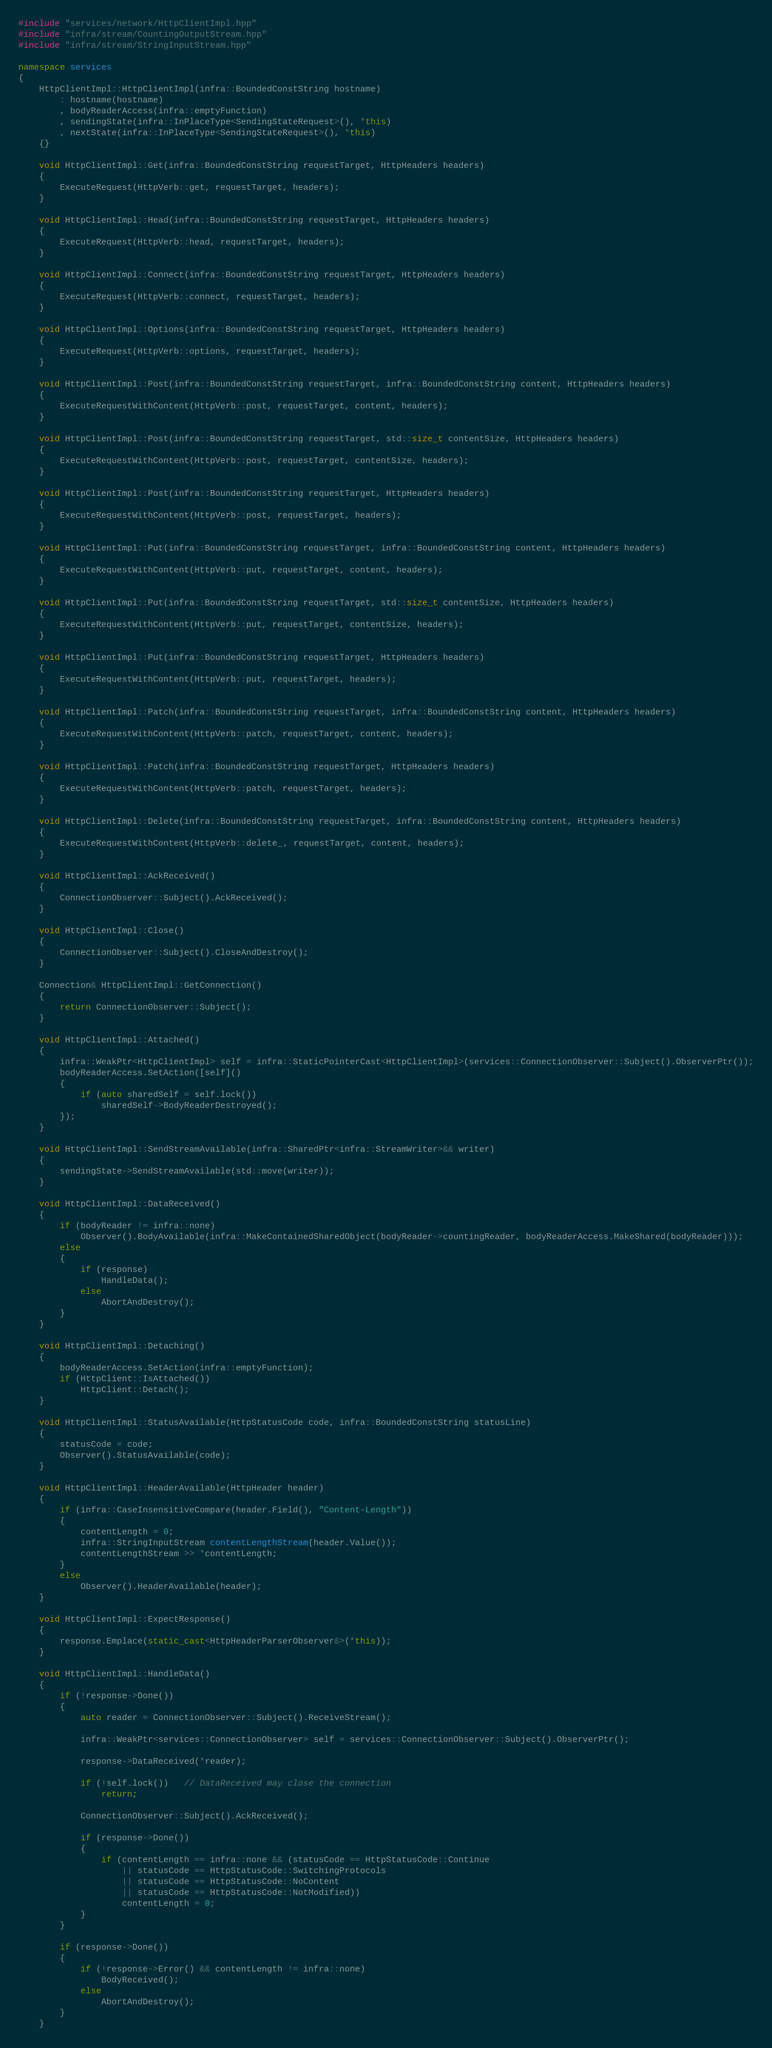<code> <loc_0><loc_0><loc_500><loc_500><_C++_>#include "services/network/HttpClientImpl.hpp"
#include "infra/stream/CountingOutputStream.hpp"
#include "infra/stream/StringInputStream.hpp"

namespace services
{
    HttpClientImpl::HttpClientImpl(infra::BoundedConstString hostname)
        : hostname(hostname)
        , bodyReaderAccess(infra::emptyFunction)
        , sendingState(infra::InPlaceType<SendingStateRequest>(), *this)
        , nextState(infra::InPlaceType<SendingStateRequest>(), *this)
    {}

    void HttpClientImpl::Get(infra::BoundedConstString requestTarget, HttpHeaders headers)
    {
        ExecuteRequest(HttpVerb::get, requestTarget, headers);
    }

    void HttpClientImpl::Head(infra::BoundedConstString requestTarget, HttpHeaders headers)
    {
        ExecuteRequest(HttpVerb::head, requestTarget, headers);
    }

    void HttpClientImpl::Connect(infra::BoundedConstString requestTarget, HttpHeaders headers)
    {
        ExecuteRequest(HttpVerb::connect, requestTarget, headers);
    }

    void HttpClientImpl::Options(infra::BoundedConstString requestTarget, HttpHeaders headers)
    {
        ExecuteRequest(HttpVerb::options, requestTarget, headers);
    }

    void HttpClientImpl::Post(infra::BoundedConstString requestTarget, infra::BoundedConstString content, HttpHeaders headers)
    {
        ExecuteRequestWithContent(HttpVerb::post, requestTarget, content, headers);
    }

    void HttpClientImpl::Post(infra::BoundedConstString requestTarget, std::size_t contentSize, HttpHeaders headers)
    {
        ExecuteRequestWithContent(HttpVerb::post, requestTarget, contentSize, headers);
    }

    void HttpClientImpl::Post(infra::BoundedConstString requestTarget, HttpHeaders headers)
    {
        ExecuteRequestWithContent(HttpVerb::post, requestTarget, headers);
    }

    void HttpClientImpl::Put(infra::BoundedConstString requestTarget, infra::BoundedConstString content, HttpHeaders headers)
    {
        ExecuteRequestWithContent(HttpVerb::put, requestTarget, content, headers);
    }

    void HttpClientImpl::Put(infra::BoundedConstString requestTarget, std::size_t contentSize, HttpHeaders headers)
    {
        ExecuteRequestWithContent(HttpVerb::put, requestTarget, contentSize, headers);
    }

    void HttpClientImpl::Put(infra::BoundedConstString requestTarget, HttpHeaders headers)
    {
        ExecuteRequestWithContent(HttpVerb::put, requestTarget, headers);
    }

    void HttpClientImpl::Patch(infra::BoundedConstString requestTarget, infra::BoundedConstString content, HttpHeaders headers)
    {
        ExecuteRequestWithContent(HttpVerb::patch, requestTarget, content, headers);
    }

    void HttpClientImpl::Patch(infra::BoundedConstString requestTarget, HttpHeaders headers)
    {
        ExecuteRequestWithContent(HttpVerb::patch, requestTarget, headers);
    }

    void HttpClientImpl::Delete(infra::BoundedConstString requestTarget, infra::BoundedConstString content, HttpHeaders headers)
    {
        ExecuteRequestWithContent(HttpVerb::delete_, requestTarget, content, headers);
    }

    void HttpClientImpl::AckReceived()
    {
        ConnectionObserver::Subject().AckReceived();
    }

    void HttpClientImpl::Close()
    {
        ConnectionObserver::Subject().CloseAndDestroy();
    }

    Connection& HttpClientImpl::GetConnection()
    {
        return ConnectionObserver::Subject();
    }

    void HttpClientImpl::Attached()
    {
        infra::WeakPtr<HttpClientImpl> self = infra::StaticPointerCast<HttpClientImpl>(services::ConnectionObserver::Subject().ObserverPtr());
        bodyReaderAccess.SetAction([self]()
        {
            if (auto sharedSelf = self.lock())
                sharedSelf->BodyReaderDestroyed();
        });
    }

    void HttpClientImpl::SendStreamAvailable(infra::SharedPtr<infra::StreamWriter>&& writer)
    {
        sendingState->SendStreamAvailable(std::move(writer));
    }

    void HttpClientImpl::DataReceived()
    {
        if (bodyReader != infra::none)
            Observer().BodyAvailable(infra::MakeContainedSharedObject(bodyReader->countingReader, bodyReaderAccess.MakeShared(bodyReader)));
        else
        {
            if (response)
                HandleData();
            else
                AbortAndDestroy();
        }
    }

    void HttpClientImpl::Detaching()
    {
        bodyReaderAccess.SetAction(infra::emptyFunction);
        if (HttpClient::IsAttached())
            HttpClient::Detach();
    }

    void HttpClientImpl::StatusAvailable(HttpStatusCode code, infra::BoundedConstString statusLine)
    {
        statusCode = code;
        Observer().StatusAvailable(code);
    }

    void HttpClientImpl::HeaderAvailable(HttpHeader header)
    {
        if (infra::CaseInsensitiveCompare(header.Field(), "Content-Length"))
        {
            contentLength = 0;
            infra::StringInputStream contentLengthStream(header.Value());
            contentLengthStream >> *contentLength;
        }
        else
            Observer().HeaderAvailable(header);
    }

    void HttpClientImpl::ExpectResponse()
    {
        response.Emplace(static_cast<HttpHeaderParserObserver&>(*this));
    }

    void HttpClientImpl::HandleData()
    {
        if (!response->Done())
        {
            auto reader = ConnectionObserver::Subject().ReceiveStream();

            infra::WeakPtr<services::ConnectionObserver> self = services::ConnectionObserver::Subject().ObserverPtr();

            response->DataReceived(*reader);

            if (!self.lock())   // DataReceived may close the connection
                return;

            ConnectionObserver::Subject().AckReceived();

            if (response->Done())
            {
                if (contentLength == infra::none && (statusCode == HttpStatusCode::Continue
                    || statusCode == HttpStatusCode::SwitchingProtocols
                    || statusCode == HttpStatusCode::NoContent
                    || statusCode == HttpStatusCode::NotModified))
                    contentLength = 0;
            }
        }

        if (response->Done())
        {
            if (!response->Error() && contentLength != infra::none)
                BodyReceived();
            else
                AbortAndDestroy();
        }
    }
</code> 